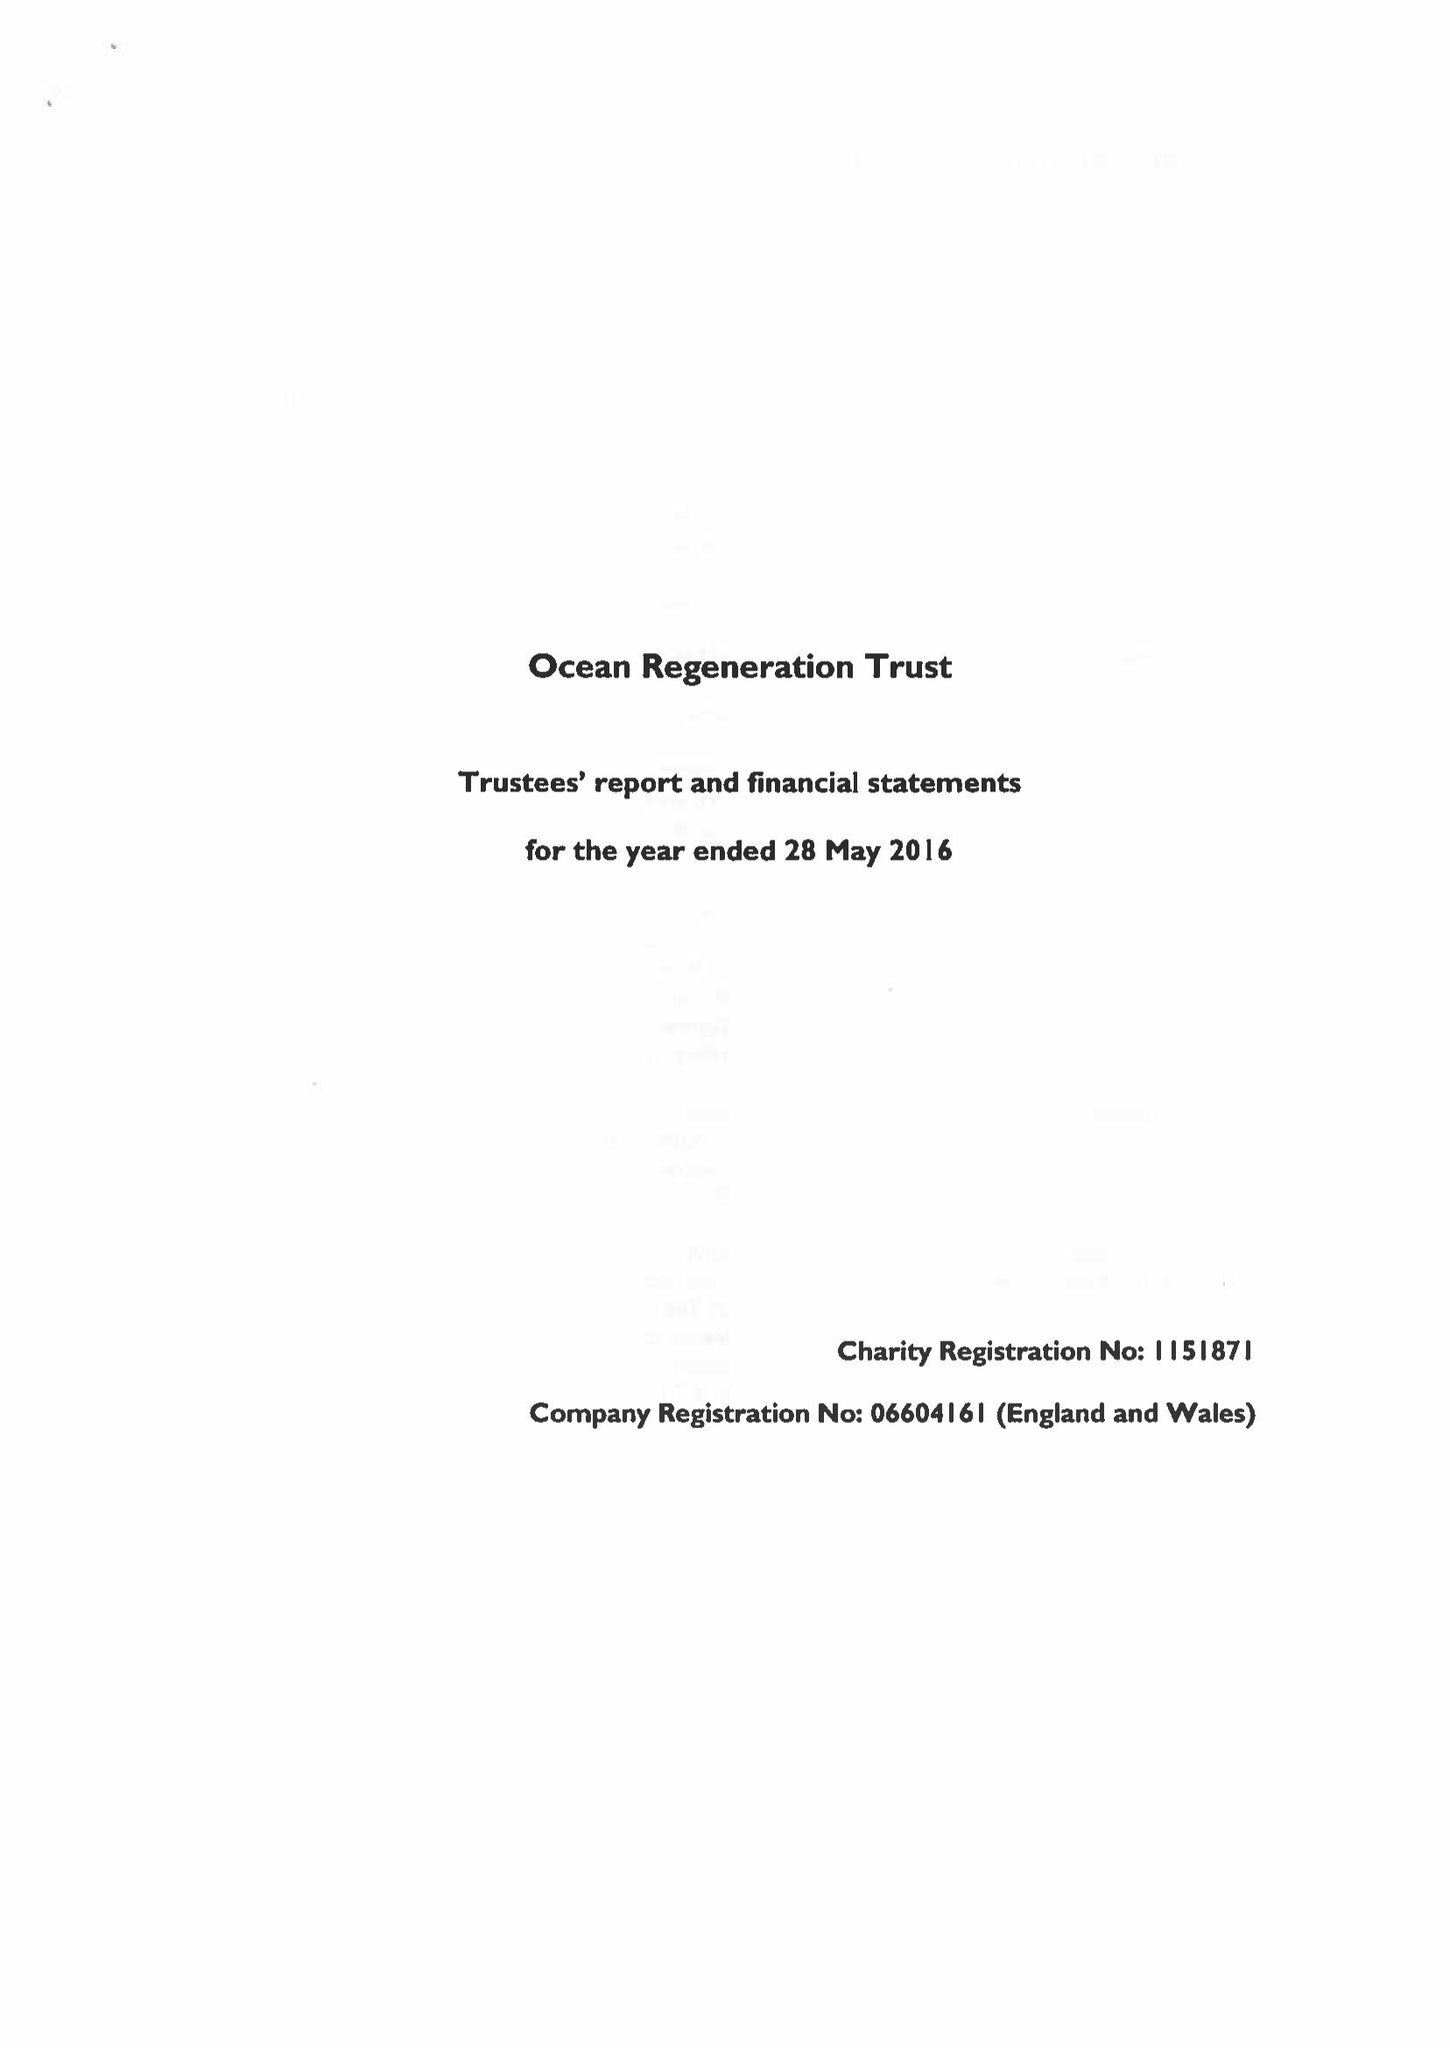What is the value for the charity_number?
Answer the question using a single word or phrase. 1151871 